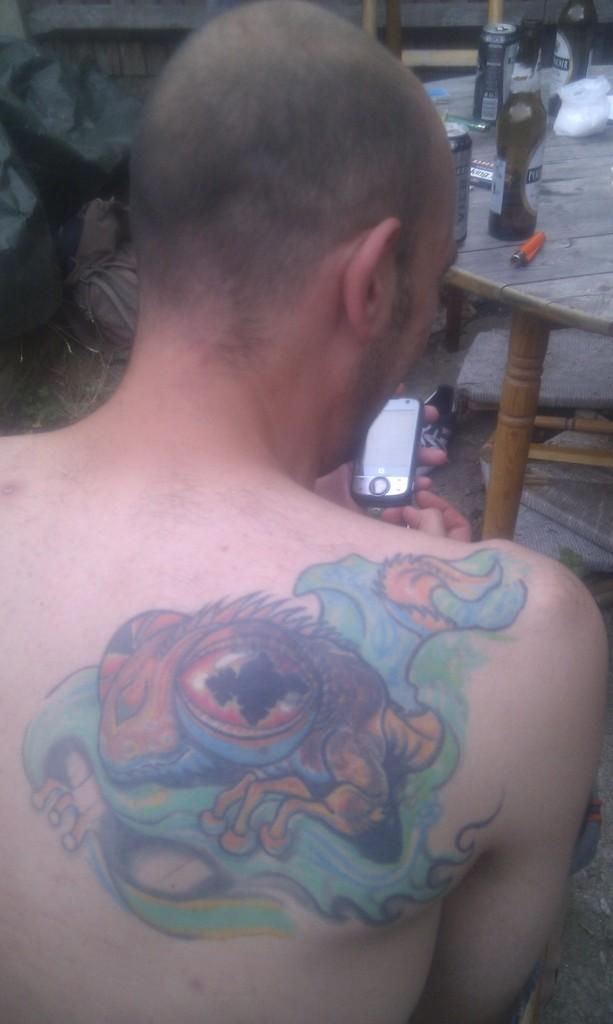What is the main subject of the image? There is a person in the image. Can you describe any distinguishing features of the person? The person has a tattoo on their back. What is the person holding in their hands? The person is holding a phone in their hands. What is in front of the person? There is a table in front of the person. What can be seen on the table? There are bottles on the table. What type of mass can be seen on the person's badge in the image? There is no badge or mass present in the image. What type of humor is displayed by the person in the image? There is no indication of humor in the image; it simply shows a person holding a phone with a tattoo on their back. 